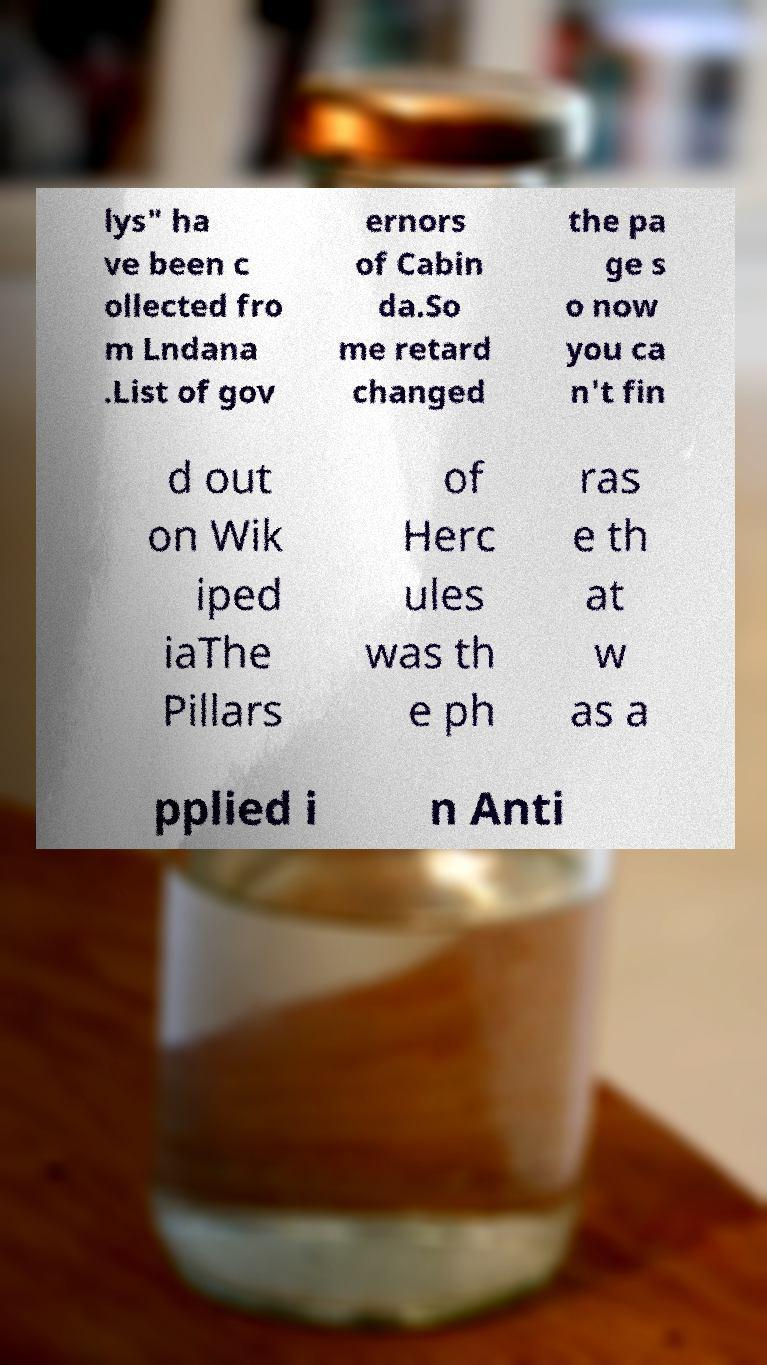There's text embedded in this image that I need extracted. Can you transcribe it verbatim? lys" ha ve been c ollected fro m Lndana .List of gov ernors of Cabin da.So me retard changed the pa ge s o now you ca n't fin d out on Wik iped iaThe Pillars of Herc ules was th e ph ras e th at w as a pplied i n Anti 